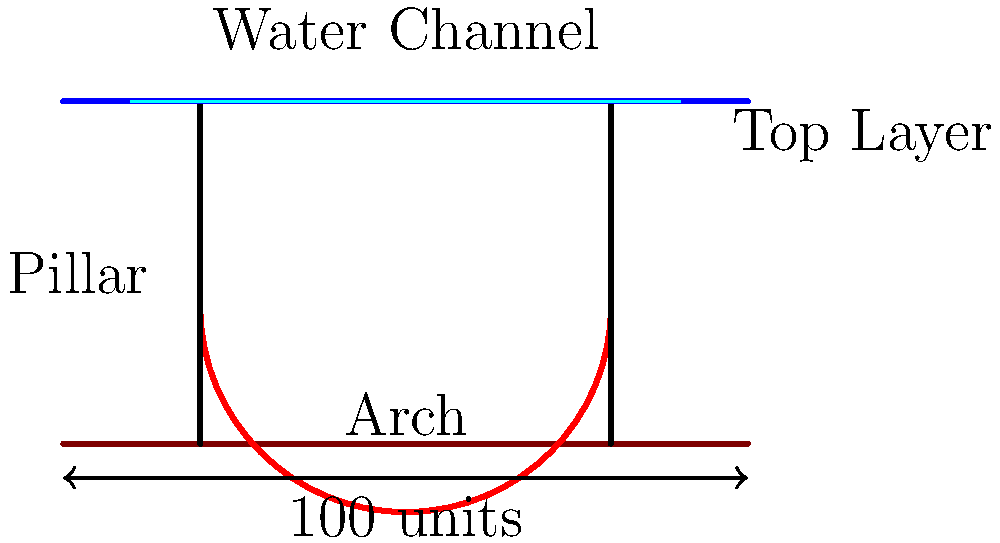In the cross-section diagram of an ancient Roman aqueduct shown above, what structural element allows for the efficient distribution of weight and enables the aqueduct to span long distances while maintaining stability? To answer this question, let's analyze the key structural elements of the Roman aqueduct:

1. Pillars: These vertical supports transfer the weight of the structure to the ground.

2. Top Layer: This horizontal element connects the pillars and supports the water channel.

3. Water Channel: This is the conduit through which water flows.

4. Arch: This curved structure spans the gap between the pillars.

The key to the aqueduct's ability to span long distances while maintaining stability lies in the arch. Here's why:

1. Weight Distribution: The arch efficiently distributes the weight of the structure and the water it carries to the pillars on either side.

2. Compressive Force: The curved shape of the arch converts the downward force of the weight above it into compressive forces along its curve.

3. Material Strength: Roman concrete (opus caementicium) used in these structures was particularly strong in compression, making the arch an ideal form.

4. Reduced Material: The arch allows for less material to be used compared to a solid wall, making the structure lighter and more economical.

5. Spanning Capability: Arches can span much greater distances than straight beams of the same material.

6. Stability: The arch's shape provides inherent stability, as the forces are directed downward and outward to the pillars.

The use of arches was a significant innovation in Roman engineering, allowing them to create large-scale, long-lasting structures like aqueducts that could efficiently transport water over long distances.
Answer: The arch 